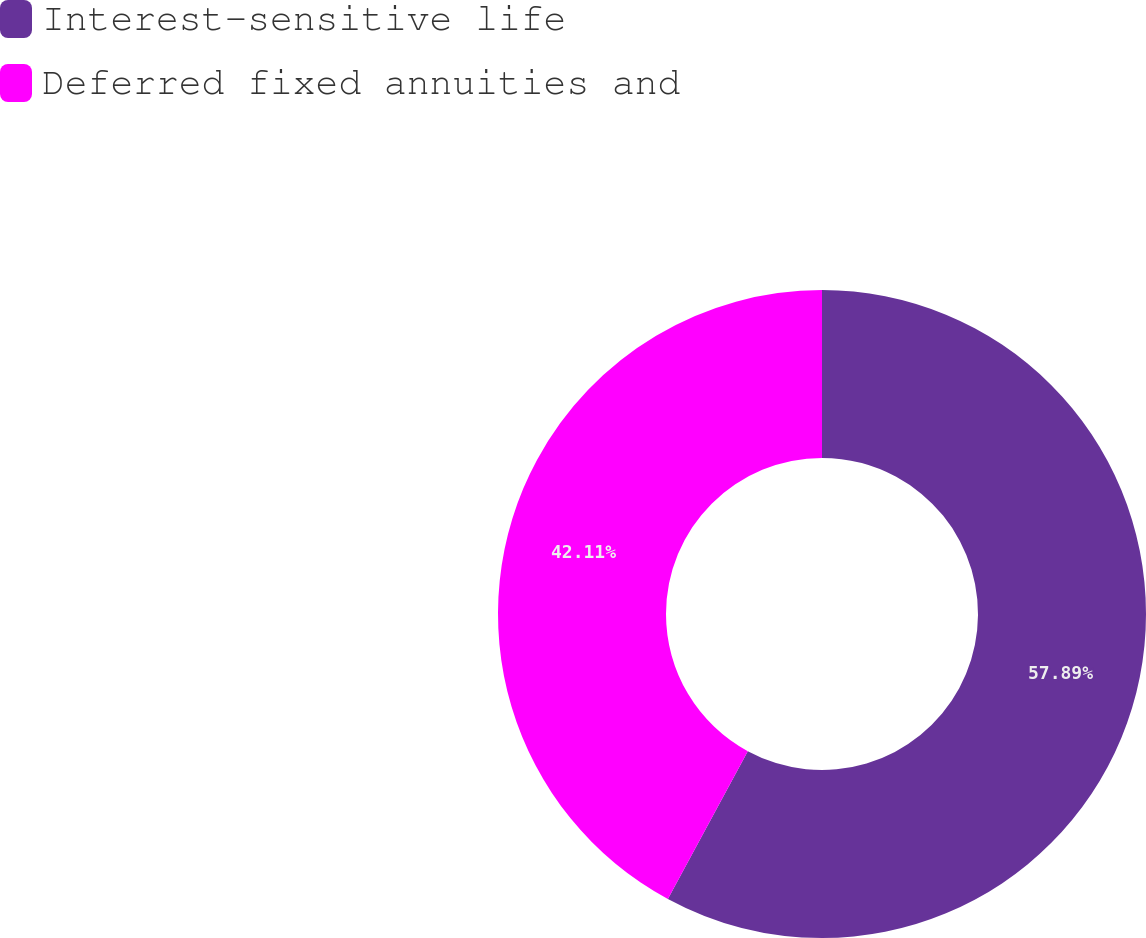Convert chart to OTSL. <chart><loc_0><loc_0><loc_500><loc_500><pie_chart><fcel>Interest-sensitive life<fcel>Deferred fixed annuities and<nl><fcel>57.89%<fcel>42.11%<nl></chart> 